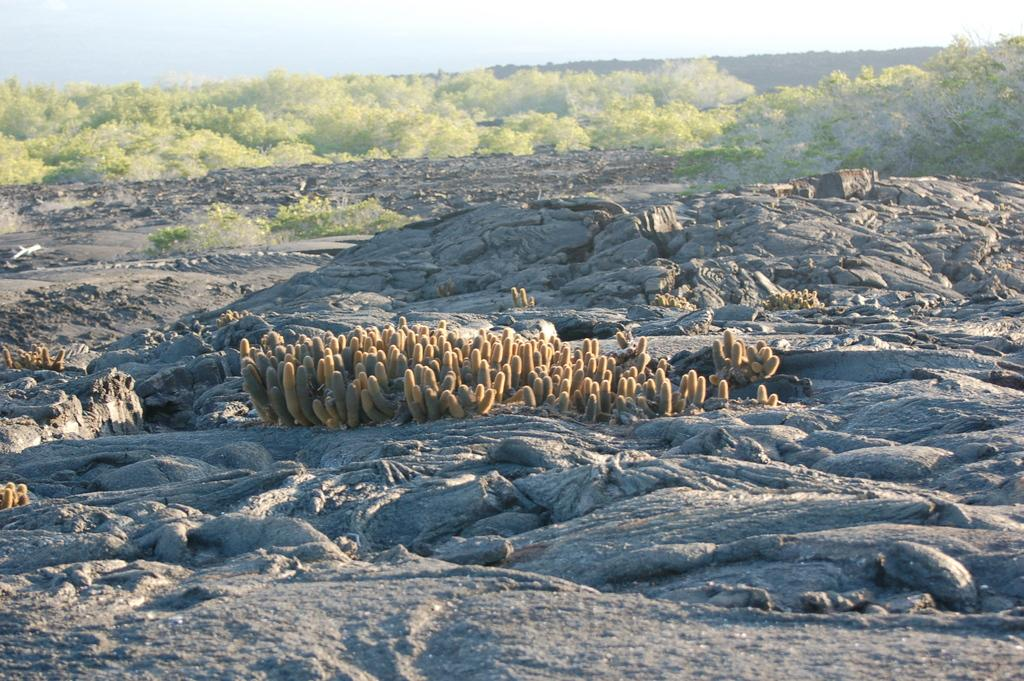What type of vegetation can be seen in the image? There are many trees, plants, and bushes in the image. Are there any specific types of plants in the image? Yes, there are cacti on rocky terrain in the image. What is visible at the top of the image? The sky is visible at the top of the image. How many eyes can be seen on the governor in the image? There is no governor or eyes present in the image. What type of tool is being used to hammer the cacti in the image? There is no hammer or tool being used to interact with the cacti in the image. 